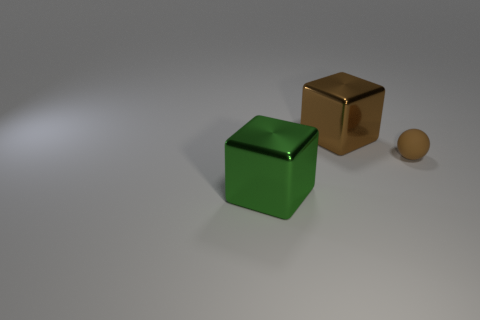There is a tiny brown object; is it the same shape as the big thing on the left side of the big brown cube?
Provide a short and direct response. No. What number of big brown shiny things are the same shape as the large green metallic object?
Keep it short and to the point. 1. There is a rubber object; what shape is it?
Keep it short and to the point. Sphere. How big is the metal cube that is in front of the thing on the right side of the large brown thing?
Ensure brevity in your answer.  Large. How many objects are brown rubber spheres or small green spheres?
Ensure brevity in your answer.  1. Is the small object the same shape as the green shiny thing?
Keep it short and to the point. No. Are there any large cubes that have the same material as the tiny brown sphere?
Your response must be concise. No. There is a large block on the right side of the big green thing; is there a brown object that is in front of it?
Your answer should be very brief. Yes. There is a brown thing on the right side of the brown metallic block; does it have the same size as the green cube?
Your answer should be very brief. No. The brown ball has what size?
Offer a very short reply. Small. 